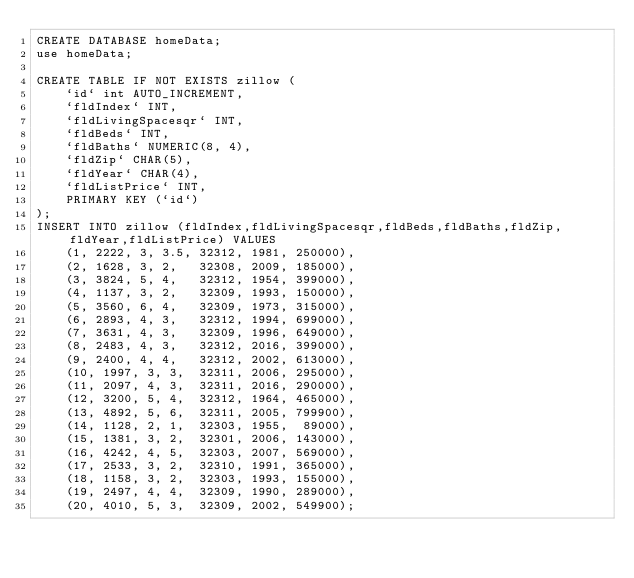Convert code to text. <code><loc_0><loc_0><loc_500><loc_500><_SQL_>CREATE DATABASE homeData;
use homeData;

CREATE TABLE IF NOT EXISTS zillow (
    `id` int AUTO_INCREMENT,
    `fldIndex` INT,
    `fldLivingSpacesqr` INT,
    `fldBeds` INT,
    `fldBaths` NUMERIC(8, 4),
    `fldZip` CHAR(5),
    `fldYear` CHAR(4),
    `fldListPrice` INT,
    PRIMARY KEY (`id`)
);
INSERT INTO zillow (fldIndex,fldLivingSpacesqr,fldBeds,fldBaths,fldZip,fldYear,fldListPrice) VALUES
    (1, 2222, 3, 3.5, 32312, 1981, 250000),
    (2, 1628, 3, 2,   32308, 2009, 185000),
    (3, 3824, 5, 4,   32312, 1954, 399000),
    (4, 1137, 3, 2,   32309, 1993, 150000),
    (5, 3560, 6, 4,   32309, 1973, 315000),
    (6, 2893, 4, 3,   32312, 1994, 699000),
    (7, 3631, 4, 3,   32309, 1996, 649000),
    (8, 2483, 4, 3,   32312, 2016, 399000),
    (9, 2400, 4, 4,   32312, 2002, 613000),
    (10, 1997, 3, 3,  32311, 2006, 295000),
    (11, 2097, 4, 3,  32311, 2016, 290000),
    (12, 3200, 5, 4,  32312, 1964, 465000),
    (13, 4892, 5, 6,  32311, 2005, 799900),
    (14, 1128, 2, 1,  32303, 1955,  89000),
    (15, 1381, 3, 2,  32301, 2006, 143000),
    (16, 4242, 4, 5,  32303, 2007, 569000),
    (17, 2533, 3, 2,  32310, 1991, 365000),
    (18, 1158, 3, 2,  32303, 1993, 155000),
    (19, 2497, 4, 4,  32309, 1990, 289000),
    (20, 4010, 5, 3,  32309, 2002, 549900);</code> 